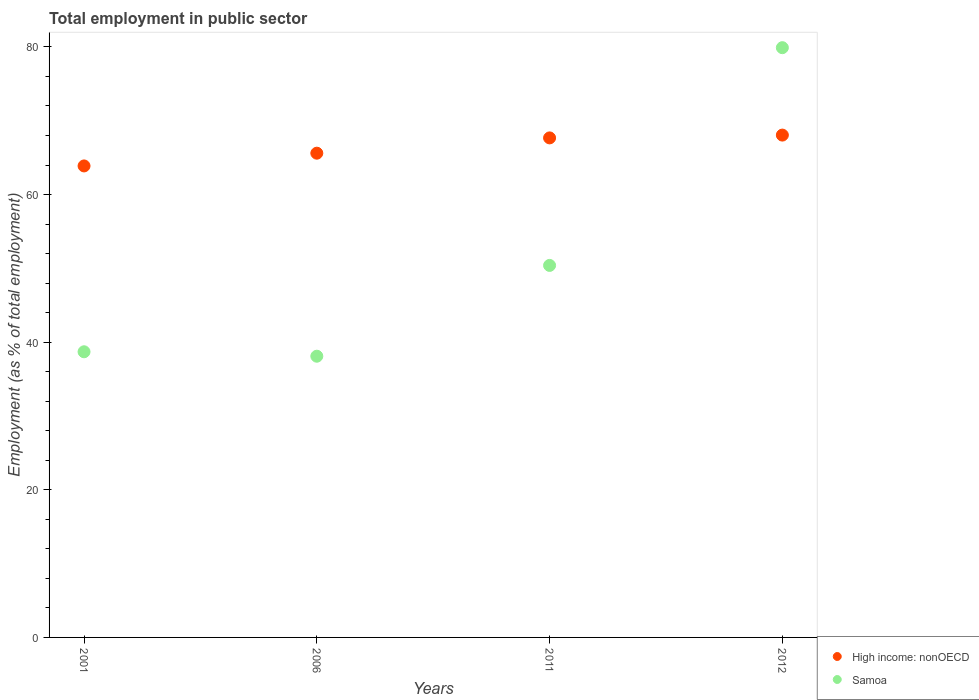How many different coloured dotlines are there?
Your answer should be very brief. 2. Is the number of dotlines equal to the number of legend labels?
Your response must be concise. Yes. What is the employment in public sector in Samoa in 2001?
Your response must be concise. 38.7. Across all years, what is the maximum employment in public sector in Samoa?
Make the answer very short. 79.9. Across all years, what is the minimum employment in public sector in Samoa?
Ensure brevity in your answer.  38.1. In which year was the employment in public sector in High income: nonOECD maximum?
Keep it short and to the point. 2012. In which year was the employment in public sector in Samoa minimum?
Provide a succinct answer. 2006. What is the total employment in public sector in Samoa in the graph?
Your response must be concise. 207.1. What is the difference between the employment in public sector in High income: nonOECD in 2001 and that in 2006?
Provide a succinct answer. -1.73. What is the difference between the employment in public sector in High income: nonOECD in 2006 and the employment in public sector in Samoa in 2012?
Keep it short and to the point. -14.29. What is the average employment in public sector in High income: nonOECD per year?
Offer a very short reply. 66.3. In the year 2012, what is the difference between the employment in public sector in Samoa and employment in public sector in High income: nonOECD?
Your answer should be compact. 11.84. In how many years, is the employment in public sector in Samoa greater than 68 %?
Your answer should be compact. 1. What is the ratio of the employment in public sector in High income: nonOECD in 2011 to that in 2012?
Provide a short and direct response. 0.99. What is the difference between the highest and the second highest employment in public sector in Samoa?
Your response must be concise. 29.5. What is the difference between the highest and the lowest employment in public sector in High income: nonOECD?
Provide a short and direct response. 4.18. Is the sum of the employment in public sector in Samoa in 2001 and 2012 greater than the maximum employment in public sector in High income: nonOECD across all years?
Provide a short and direct response. Yes. Is the employment in public sector in Samoa strictly less than the employment in public sector in High income: nonOECD over the years?
Keep it short and to the point. No. How many dotlines are there?
Make the answer very short. 2. How many years are there in the graph?
Your response must be concise. 4. Are the values on the major ticks of Y-axis written in scientific E-notation?
Provide a short and direct response. No. Does the graph contain any zero values?
Make the answer very short. No. Does the graph contain grids?
Provide a short and direct response. No. What is the title of the graph?
Provide a succinct answer. Total employment in public sector. What is the label or title of the Y-axis?
Ensure brevity in your answer.  Employment (as % of total employment). What is the Employment (as % of total employment) in High income: nonOECD in 2001?
Your answer should be very brief. 63.88. What is the Employment (as % of total employment) in Samoa in 2001?
Offer a very short reply. 38.7. What is the Employment (as % of total employment) of High income: nonOECD in 2006?
Offer a terse response. 65.61. What is the Employment (as % of total employment) of Samoa in 2006?
Give a very brief answer. 38.1. What is the Employment (as % of total employment) in High income: nonOECD in 2011?
Make the answer very short. 67.68. What is the Employment (as % of total employment) in Samoa in 2011?
Ensure brevity in your answer.  50.4. What is the Employment (as % of total employment) in High income: nonOECD in 2012?
Provide a succinct answer. 68.06. What is the Employment (as % of total employment) in Samoa in 2012?
Provide a succinct answer. 79.9. Across all years, what is the maximum Employment (as % of total employment) of High income: nonOECD?
Your response must be concise. 68.06. Across all years, what is the maximum Employment (as % of total employment) in Samoa?
Your answer should be very brief. 79.9. Across all years, what is the minimum Employment (as % of total employment) in High income: nonOECD?
Make the answer very short. 63.88. Across all years, what is the minimum Employment (as % of total employment) of Samoa?
Make the answer very short. 38.1. What is the total Employment (as % of total employment) of High income: nonOECD in the graph?
Your answer should be compact. 265.22. What is the total Employment (as % of total employment) in Samoa in the graph?
Your answer should be compact. 207.1. What is the difference between the Employment (as % of total employment) in High income: nonOECD in 2001 and that in 2006?
Offer a very short reply. -1.73. What is the difference between the Employment (as % of total employment) in High income: nonOECD in 2001 and that in 2011?
Make the answer very short. -3.8. What is the difference between the Employment (as % of total employment) of High income: nonOECD in 2001 and that in 2012?
Provide a succinct answer. -4.18. What is the difference between the Employment (as % of total employment) in Samoa in 2001 and that in 2012?
Provide a short and direct response. -41.2. What is the difference between the Employment (as % of total employment) in High income: nonOECD in 2006 and that in 2011?
Provide a short and direct response. -2.07. What is the difference between the Employment (as % of total employment) of High income: nonOECD in 2006 and that in 2012?
Your answer should be very brief. -2.45. What is the difference between the Employment (as % of total employment) in Samoa in 2006 and that in 2012?
Provide a short and direct response. -41.8. What is the difference between the Employment (as % of total employment) in High income: nonOECD in 2011 and that in 2012?
Provide a short and direct response. -0.38. What is the difference between the Employment (as % of total employment) in Samoa in 2011 and that in 2012?
Your answer should be very brief. -29.5. What is the difference between the Employment (as % of total employment) in High income: nonOECD in 2001 and the Employment (as % of total employment) in Samoa in 2006?
Offer a terse response. 25.78. What is the difference between the Employment (as % of total employment) in High income: nonOECD in 2001 and the Employment (as % of total employment) in Samoa in 2011?
Offer a very short reply. 13.48. What is the difference between the Employment (as % of total employment) in High income: nonOECD in 2001 and the Employment (as % of total employment) in Samoa in 2012?
Your response must be concise. -16.02. What is the difference between the Employment (as % of total employment) in High income: nonOECD in 2006 and the Employment (as % of total employment) in Samoa in 2011?
Your answer should be very brief. 15.21. What is the difference between the Employment (as % of total employment) of High income: nonOECD in 2006 and the Employment (as % of total employment) of Samoa in 2012?
Offer a very short reply. -14.29. What is the difference between the Employment (as % of total employment) in High income: nonOECD in 2011 and the Employment (as % of total employment) in Samoa in 2012?
Offer a terse response. -12.22. What is the average Employment (as % of total employment) of High income: nonOECD per year?
Your response must be concise. 66.3. What is the average Employment (as % of total employment) of Samoa per year?
Provide a succinct answer. 51.77. In the year 2001, what is the difference between the Employment (as % of total employment) in High income: nonOECD and Employment (as % of total employment) in Samoa?
Offer a terse response. 25.18. In the year 2006, what is the difference between the Employment (as % of total employment) in High income: nonOECD and Employment (as % of total employment) in Samoa?
Ensure brevity in your answer.  27.51. In the year 2011, what is the difference between the Employment (as % of total employment) of High income: nonOECD and Employment (as % of total employment) of Samoa?
Offer a very short reply. 17.28. In the year 2012, what is the difference between the Employment (as % of total employment) in High income: nonOECD and Employment (as % of total employment) in Samoa?
Your response must be concise. -11.84. What is the ratio of the Employment (as % of total employment) in High income: nonOECD in 2001 to that in 2006?
Your answer should be very brief. 0.97. What is the ratio of the Employment (as % of total employment) of Samoa in 2001 to that in 2006?
Your answer should be very brief. 1.02. What is the ratio of the Employment (as % of total employment) of High income: nonOECD in 2001 to that in 2011?
Make the answer very short. 0.94. What is the ratio of the Employment (as % of total employment) in Samoa in 2001 to that in 2011?
Keep it short and to the point. 0.77. What is the ratio of the Employment (as % of total employment) of High income: nonOECD in 2001 to that in 2012?
Offer a very short reply. 0.94. What is the ratio of the Employment (as % of total employment) in Samoa in 2001 to that in 2012?
Offer a terse response. 0.48. What is the ratio of the Employment (as % of total employment) of High income: nonOECD in 2006 to that in 2011?
Your answer should be very brief. 0.97. What is the ratio of the Employment (as % of total employment) in Samoa in 2006 to that in 2011?
Offer a very short reply. 0.76. What is the ratio of the Employment (as % of total employment) in Samoa in 2006 to that in 2012?
Provide a succinct answer. 0.48. What is the ratio of the Employment (as % of total employment) in Samoa in 2011 to that in 2012?
Provide a succinct answer. 0.63. What is the difference between the highest and the second highest Employment (as % of total employment) of High income: nonOECD?
Provide a short and direct response. 0.38. What is the difference between the highest and the second highest Employment (as % of total employment) in Samoa?
Ensure brevity in your answer.  29.5. What is the difference between the highest and the lowest Employment (as % of total employment) in High income: nonOECD?
Your answer should be very brief. 4.18. What is the difference between the highest and the lowest Employment (as % of total employment) in Samoa?
Make the answer very short. 41.8. 